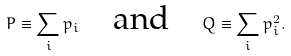Convert formula to latex. <formula><loc_0><loc_0><loc_500><loc_500>P \equiv \sum _ { i } p _ { i } \quad \text {and} \quad Q \equiv \sum _ { i } p _ { i } ^ { 2 } .</formula> 